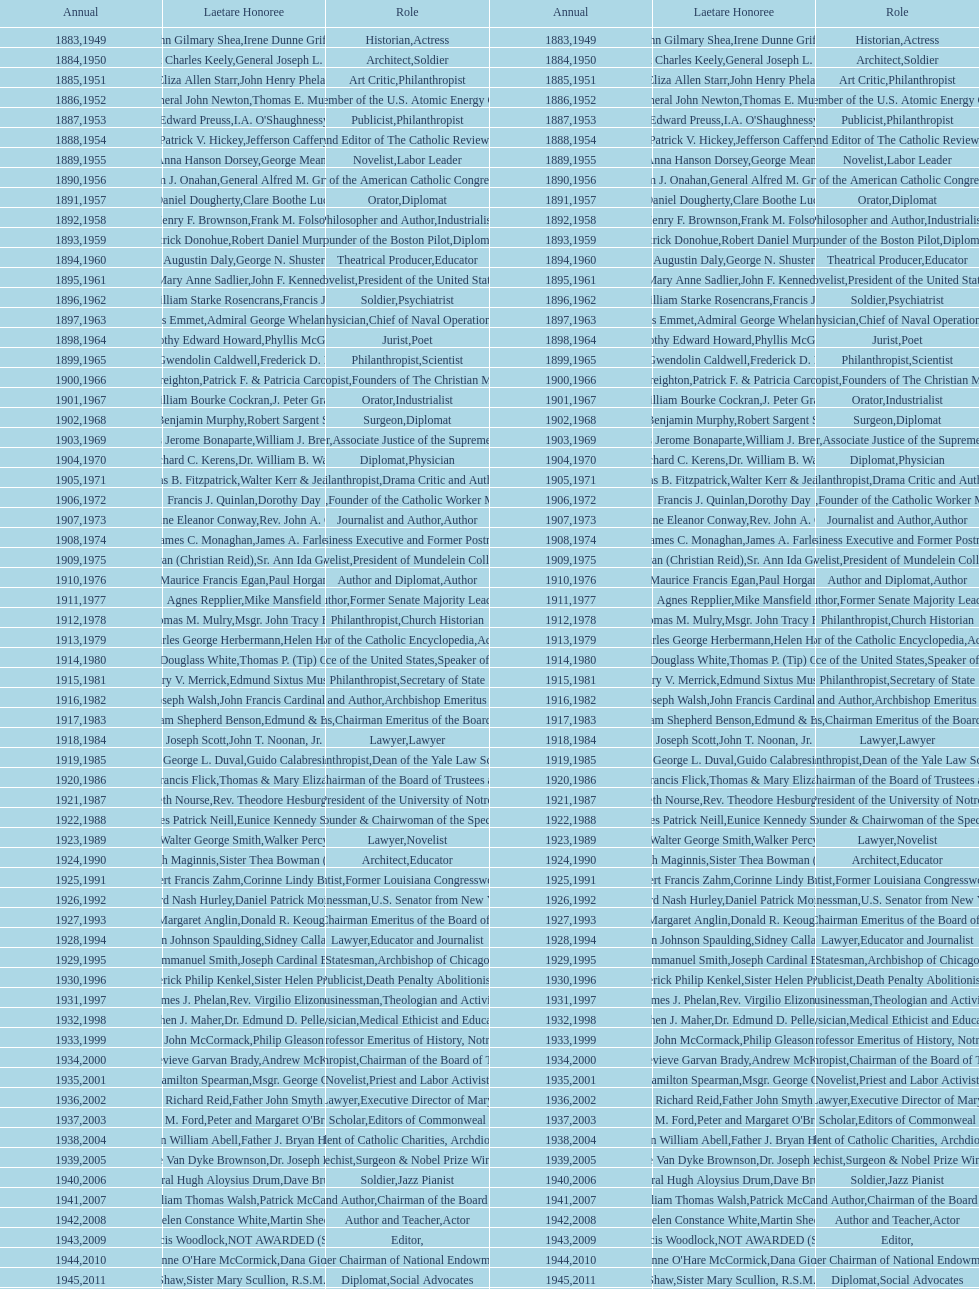What is the name of the laetare medalist listed before edward preuss? General John Newton. 